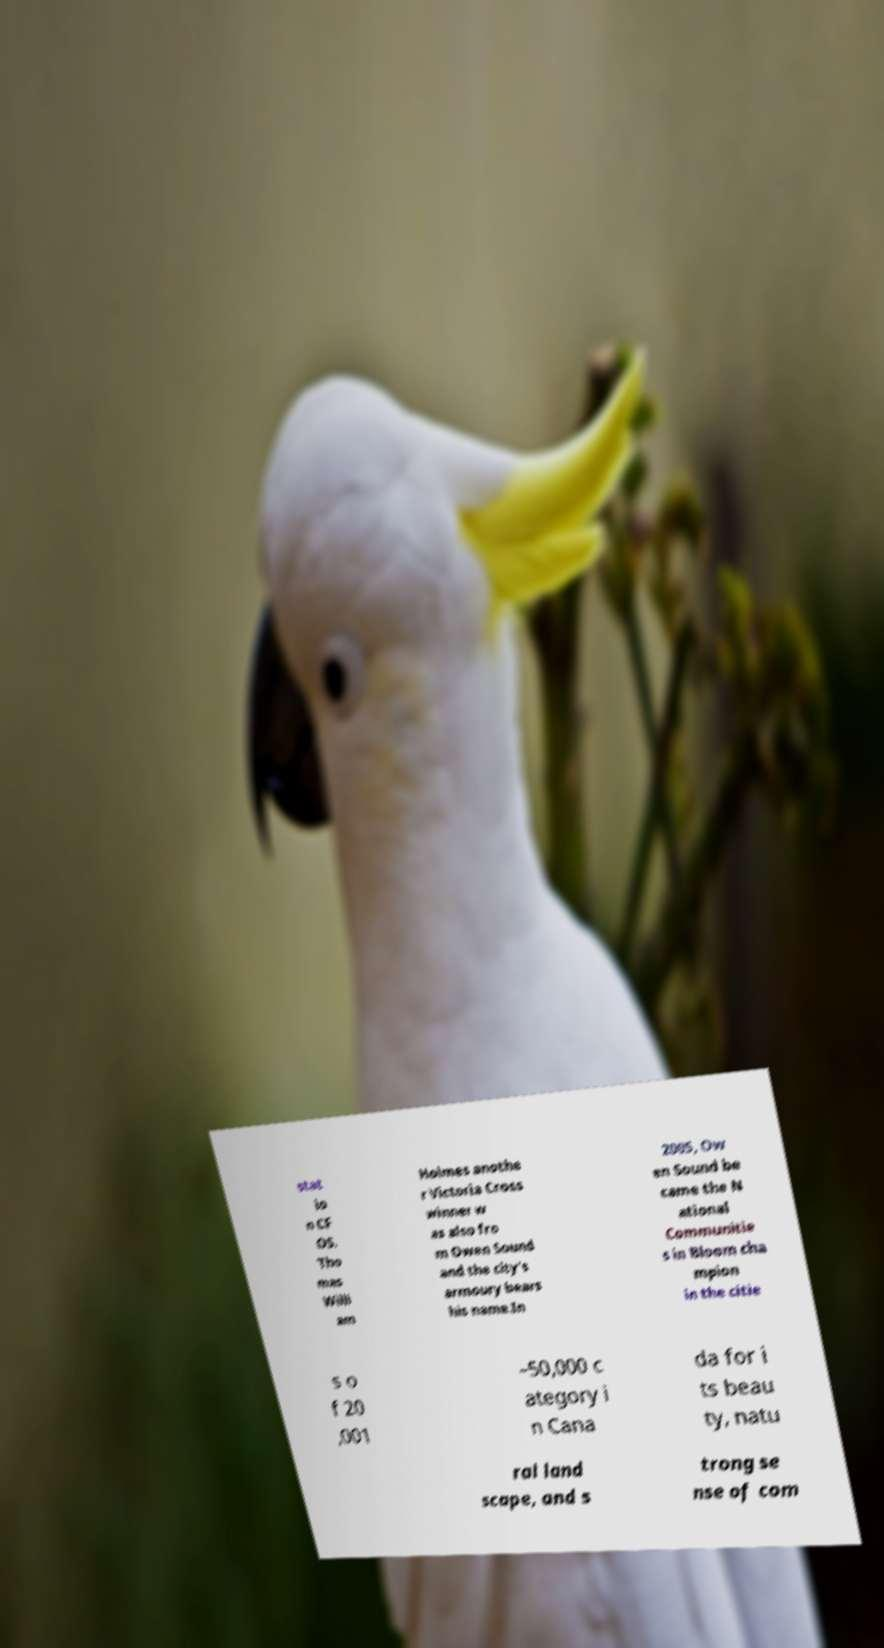Could you extract and type out the text from this image? stat io n CF OS. Tho mas Willi am Holmes anothe r Victoria Cross winner w as also fro m Owen Sound and the city's armoury bears his name.In 2005, Ow en Sound be came the N ational Communitie s in Bloom cha mpion in the citie s o f 20 ,001 –50,000 c ategory i n Cana da for i ts beau ty, natu ral land scape, and s trong se nse of com 